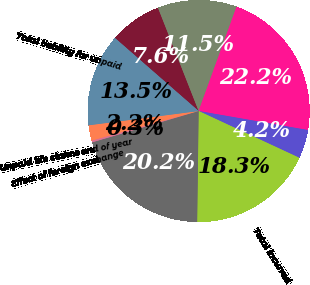<chart> <loc_0><loc_0><loc_500><loc_500><pie_chart><fcel>(In millions)<fcel>Unpaid supplemental health<fcel>Current year<fcel>Prior years<fcel>Total incurred<fcel>Total paid<fcel>Effect of foreign exchange<fcel>Unpaid life claims end of year<fcel>Total liability for unpaid<nl><fcel>7.61%<fcel>11.52%<fcel>22.2%<fcel>4.18%<fcel>18.29%<fcel>20.24%<fcel>0.27%<fcel>2.23%<fcel>13.47%<nl></chart> 